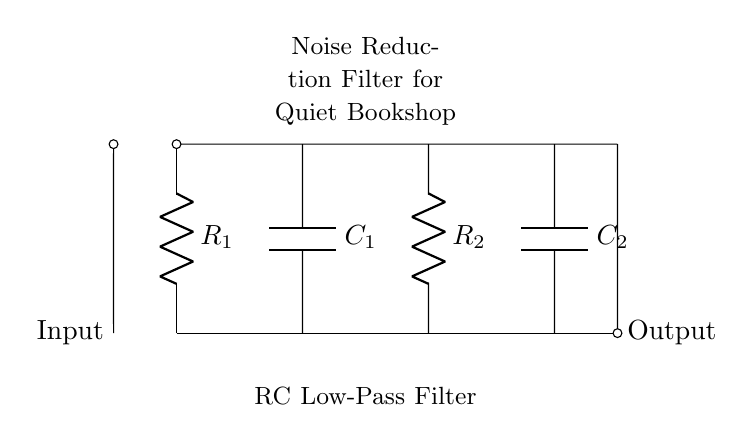What components are in the circuit? The circuit contains two resistors and two capacitors, identified as R1, R2, C1, and C2.
Answer: Two resistors, two capacitors What does the circuit function as? The circuit is designated as an RC low-pass filter, which implies its function is to allow low-frequency signals to pass while attenuating higher-frequency noise.
Answer: RC low-pass filter How many resistors are there? The circuit diagram clearly shows two components labeled as R1 and R2, signifying there are two resistors present.
Answer: Two resistors What type of filter is represented in the diagram? The circuit is identified as a noise reduction filter, specifically an RC low-pass filter, which is indicated in the diagram's title.
Answer: Noise reduction filter How are the components connected in the circuit? The resistors and capacitors are connected in a series and parallel arrangement, which is characteristic of an RC filter design where resistors and capacitors are arranged to affect frequency response.
Answer: Series and parallel connections What is the output labeled in the circuit? The output is labeled on the right side of the diagram, indicating where the processed signal exits the filter circuit.
Answer: Output What is the role of capacitors in this circuit? The role of the capacitors is to store electrical energy and help smooth out the signal, allowing only low-frequency noise to be effectively passed to the output.
Answer: Smoothing the signal 